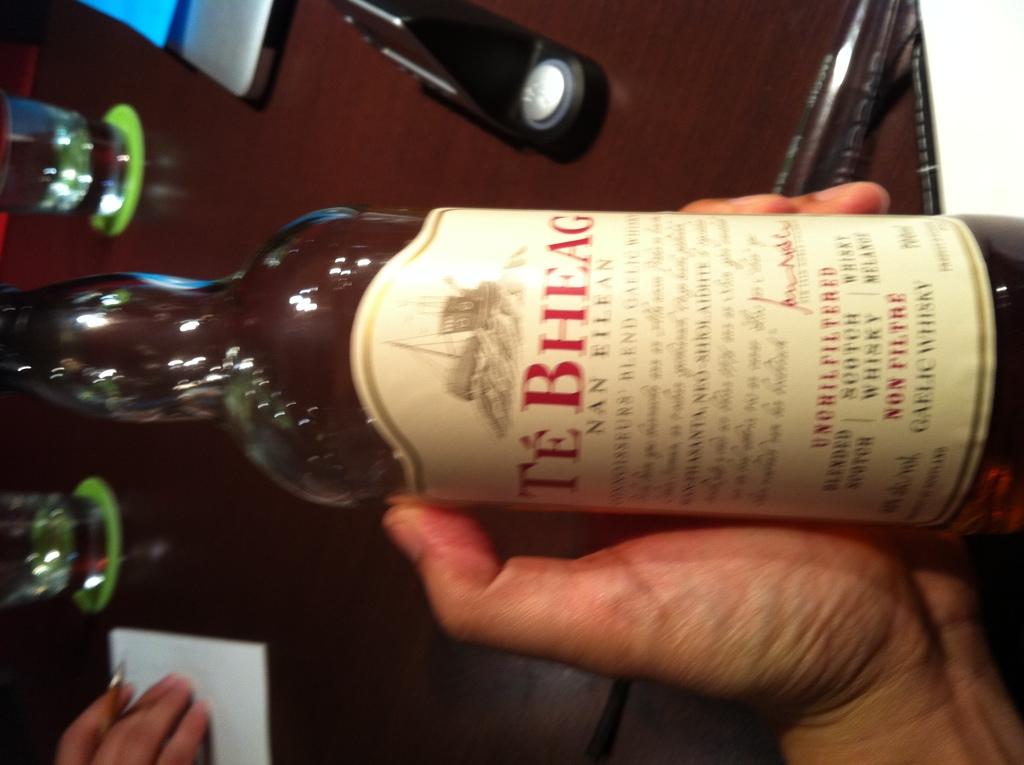What is in the bottle?
Provide a succinct answer. Te bheag. 